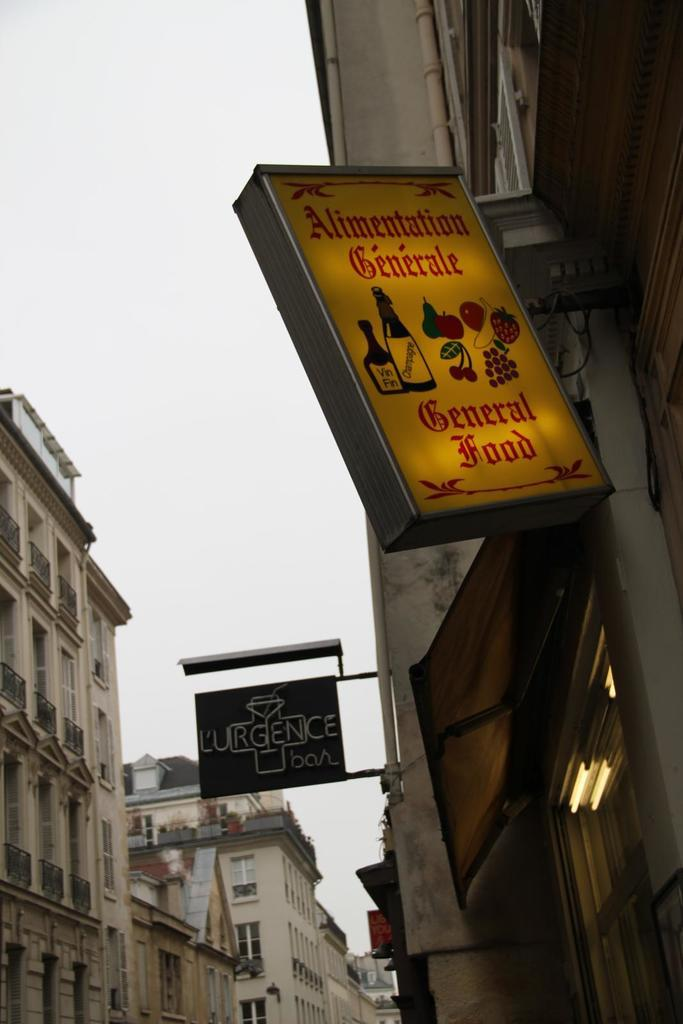Provide a one-sentence caption for the provided image. A lit up sign denoting a place for General Food or Alimentation Generale. 